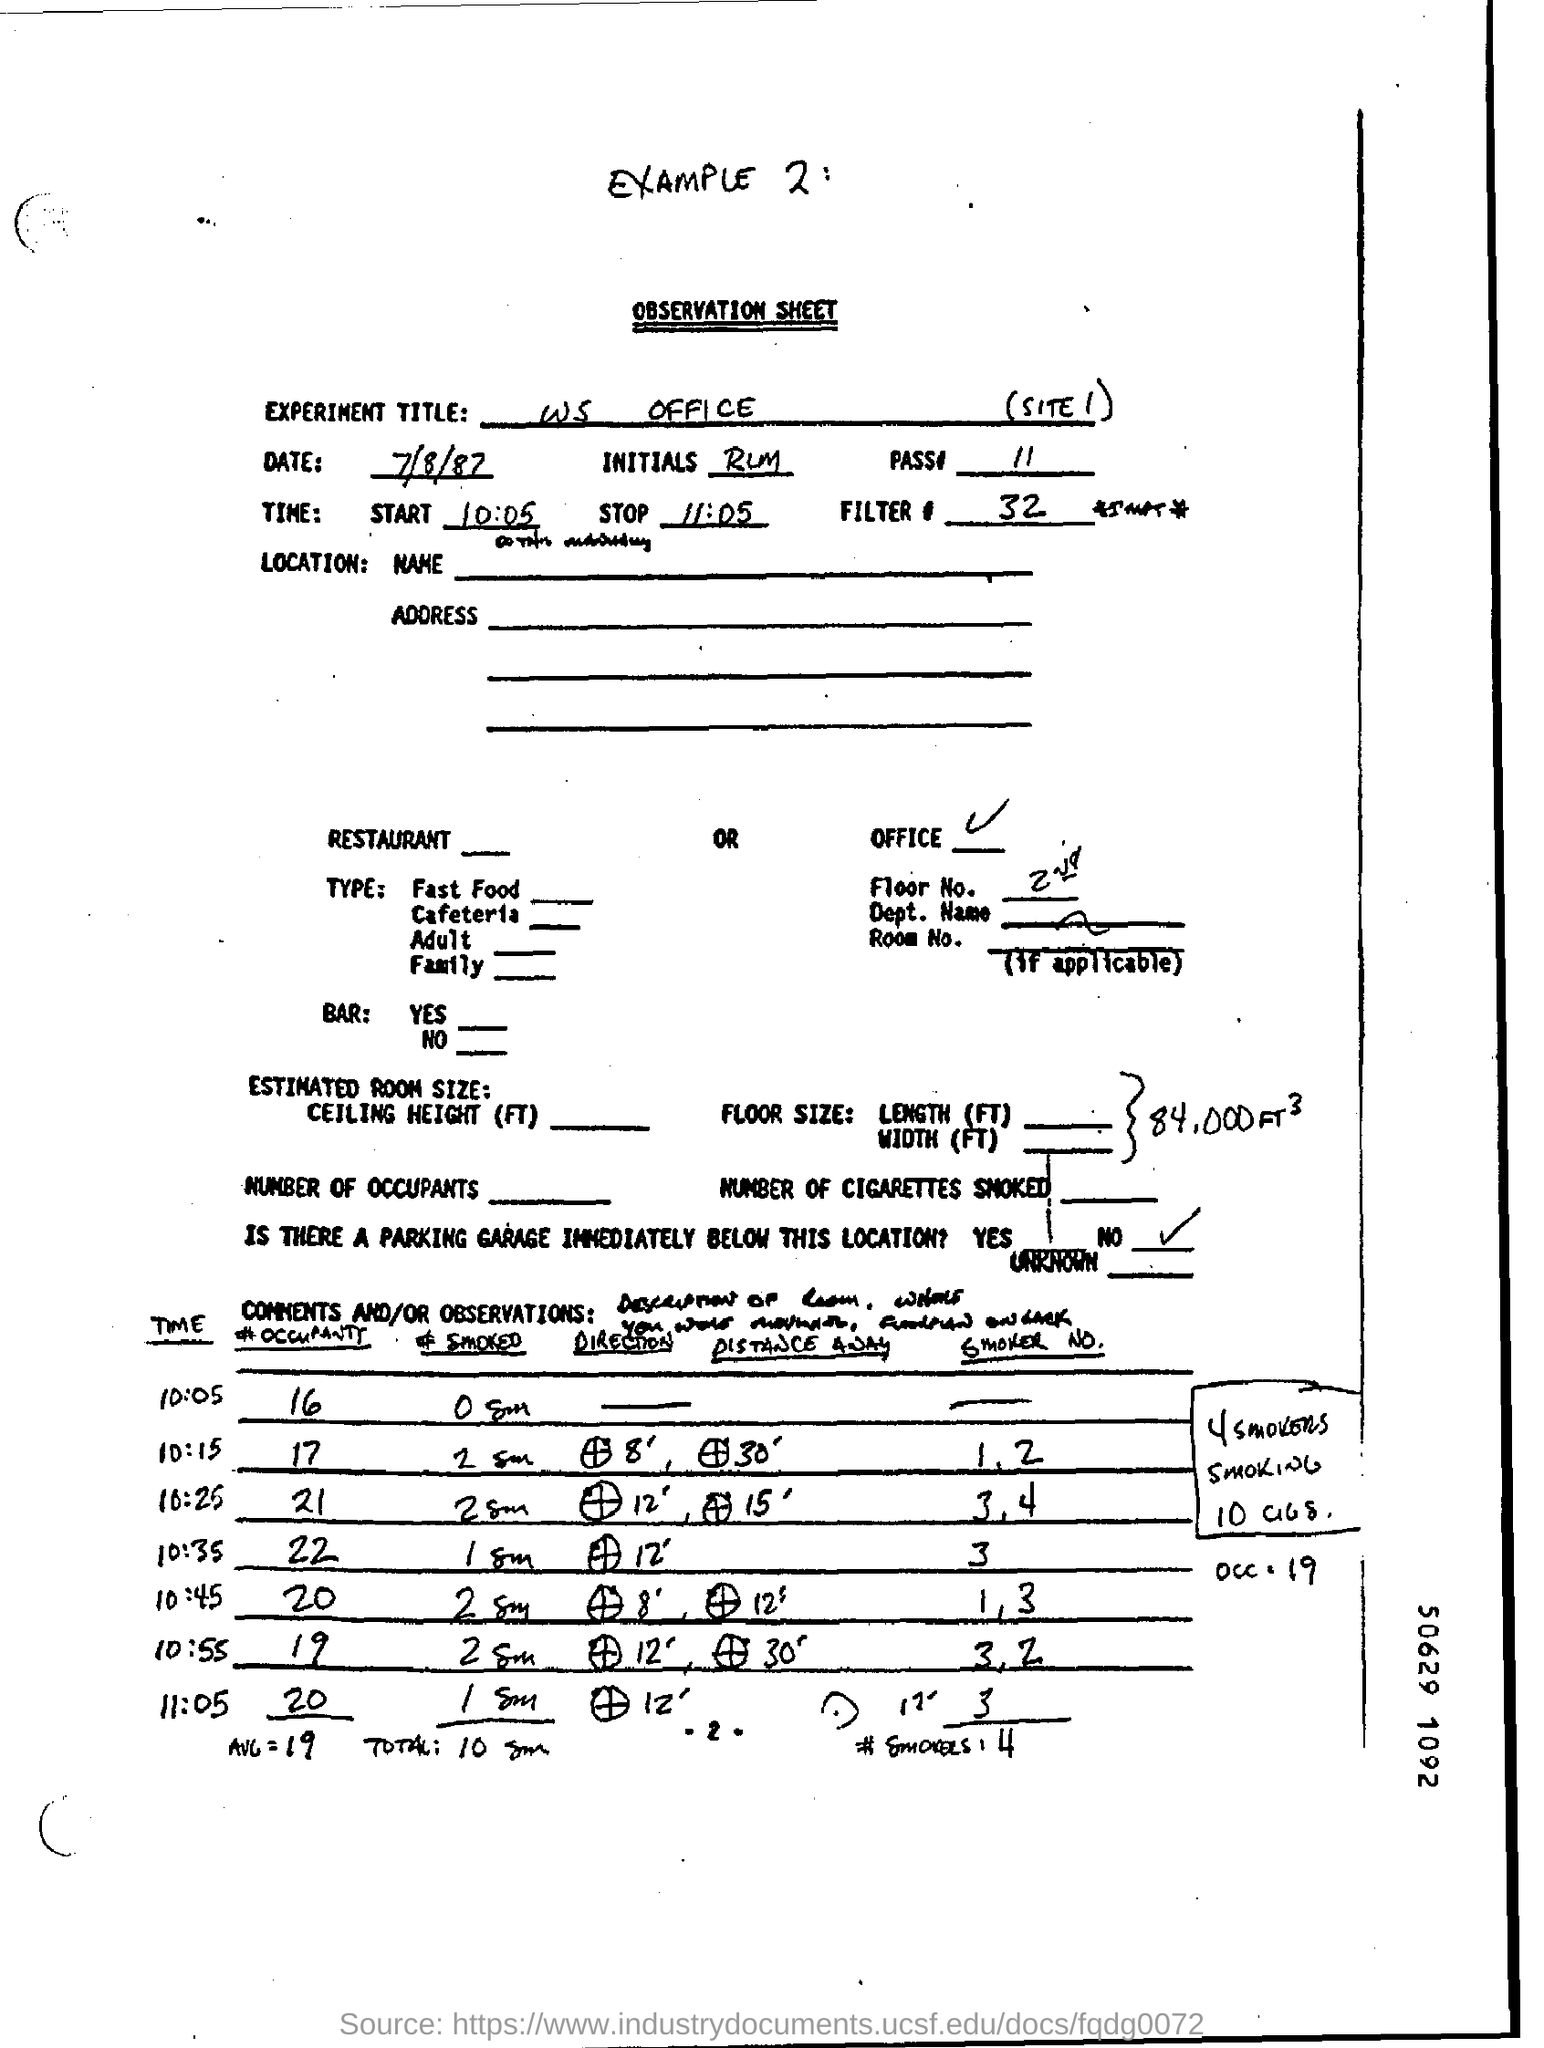What was the starting time?
Ensure brevity in your answer.  10:05. What is the stopping time?
Your answer should be compact. 11:05. 